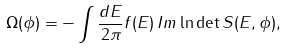Convert formula to latex. <formula><loc_0><loc_0><loc_500><loc_500>\Omega ( \phi ) = - \int \frac { d E } { 2 \pi } f ( E ) \, I m \ln \det S ( E , \phi ) ,</formula> 